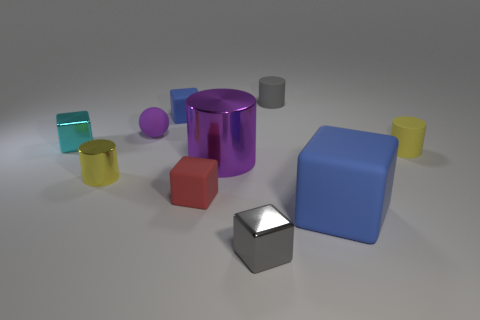There is a block behind the cyan object; does it have the same size as the small yellow shiny thing?
Offer a very short reply. Yes. Are there any purple metal objects that are on the right side of the metal block that is to the left of the tiny gray thing left of the gray matte object?
Your response must be concise. Yes. What number of metallic things are either tiny blue blocks or cubes?
Make the answer very short. 2. How many other things are there of the same shape as the tiny gray rubber object?
Your response must be concise. 3. Is the number of large blue spheres greater than the number of big blocks?
Your answer should be compact. No. There is a blue block in front of the small yellow cylinder on the left side of the gray metal object in front of the small yellow matte cylinder; what size is it?
Make the answer very short. Large. How big is the yellow cylinder that is right of the large blue matte object?
Offer a terse response. Small. How many things are cylinders or metal blocks in front of the large rubber cube?
Ensure brevity in your answer.  5. What number of other things are the same size as the yellow matte cylinder?
Ensure brevity in your answer.  7. There is a purple thing that is the same shape as the small yellow rubber object; what is its material?
Offer a terse response. Metal. 